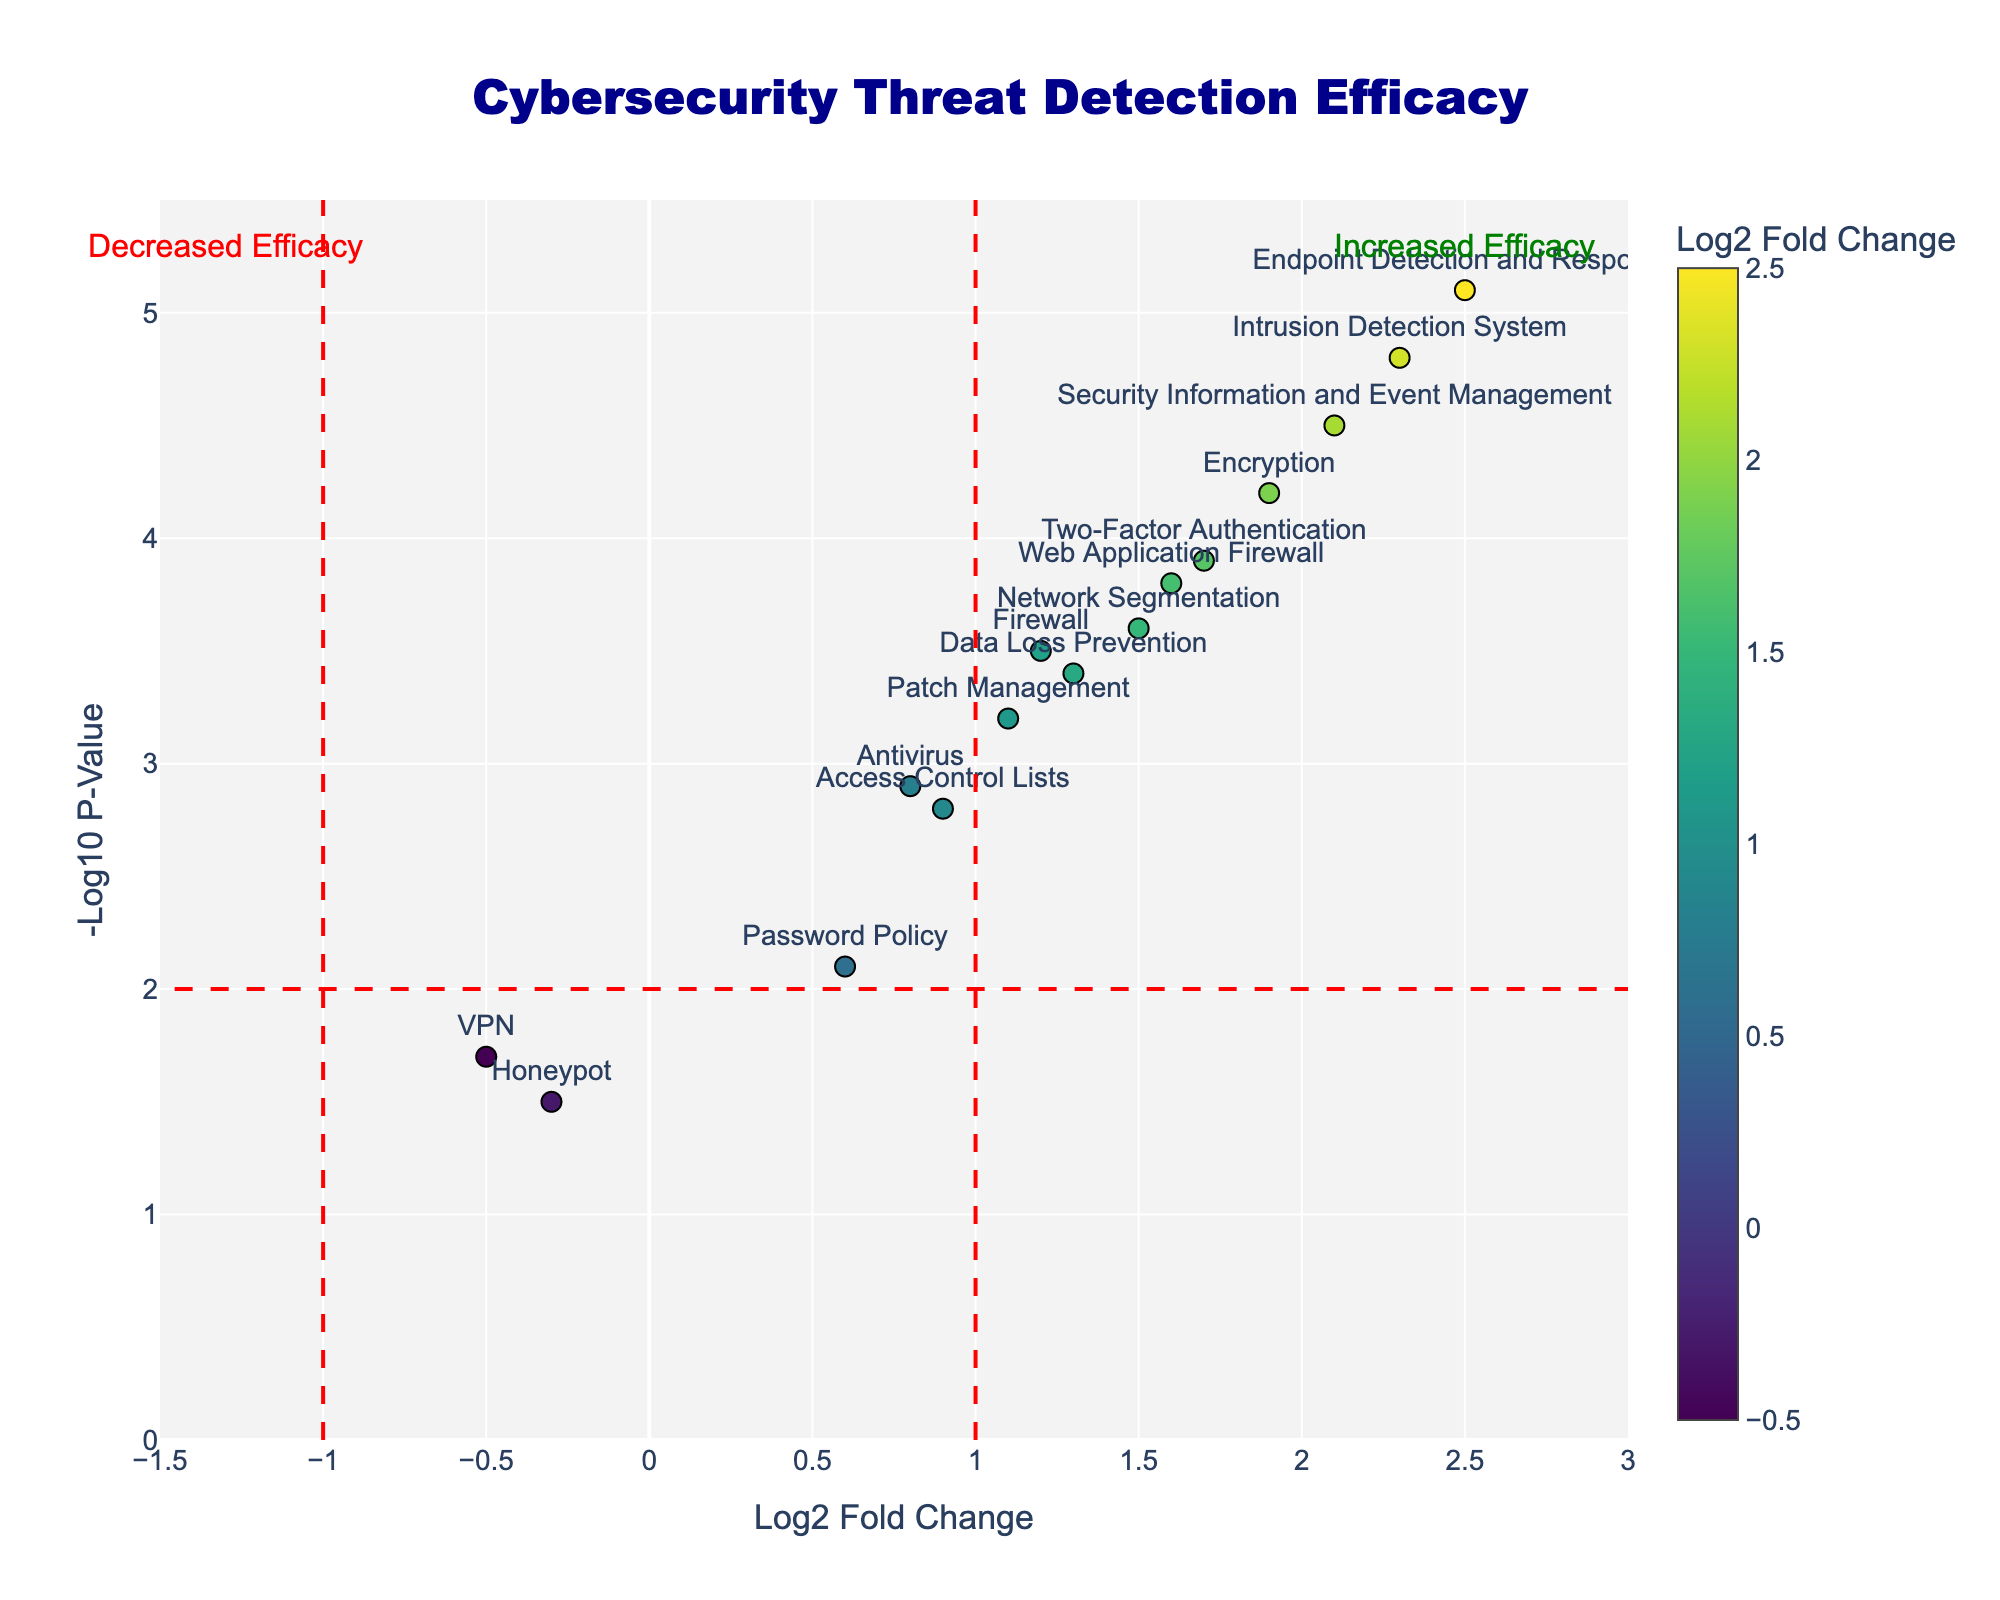What is the title of the figure? The title is usually displayed prominently at the top of the plot. Here, it is centered and reads "Cybersecurity Threat Detection Efficacy".
Answer: Cybersecurity Threat Detection Efficacy Which protocol has the highest efficacy according to the figure? To determine the protocol with the highest efficacy, look for the point highest on the y-axis. The highest point corresponds to the protocol "Endpoint Detection and Response" with Log2 Fold Change of 2.5 and a Negative Log10 P-Value of 5.1.
Answer: Endpoint Detection and Response What are the axes labels? The labels are typically found along each axis. Here, the x-axis is labeled "Log2 Fold Change" and the y-axis is labeled "-Log10 P-Value".
Answer: Log2 Fold Change and -Log10 P-Value Which security protocol shows a decrease in efficacy? A decrease in efficacy is indicated by a negative Log2 Fold Change. From the plot, the protocols with negative values on the x-axis are "VPN" and "Honeypot".
Answer: VPN and Honeypot How many protocols have a Negative Log10 P-Value higher than 4? To find this, count the points where the y-axis value is greater than 4. According to the plot, these protocols are "Intrusion Detection System", "Encryption", "Security Information and Event Management", and "Endpoint Detection and Response".
Answer: Four Which protocols fall within the increased efficacy region? The increased efficacy region is indicated by being to the right of the vertical line at x=1. The protocols in this region are "Intrusion Detection System", "Two-Factor Authentication", "Encryption", "Network Segmentation", "Security Information and Event Management", "Web Application Firewall", and "Endpoint Detection and Response".
Answer: IDS, 2FA, Encryption, Network Segmentation, SIEM, WAF, EDR Between "Firewall" and "Antivirus", which protocol has a higher efficacy and by how much? First, locate the points for "Firewall" and "Antivirus". "Firewall" has a Log2 Fold Change of 1.2, while "Antivirus" has 0.8. The difference in efficacy is 1.2 - 0.8 = 0.4.
Answer: Firewall by 0.4 What is the Log2 Fold Change of "Two-Factor Authentication"? Locate the point labeled "Two-Factor Authentication" and check its x-axis value. The Log2 Fold Change for this protocol is 1.7.
Answer: 1.7 Considering protocols with a Log2 Fold Change higher than 2, which has the lowest p-value? First, identify protocols with a Log2 Fold Change higher than 2: "Intrusion Detection System", "Security Information and Event Management", and "Endpoint Detection and Response". Among these, "Endpoint Detection and Response" has the highest point on the y-axis, corresponding to the lowest p-value.
Answer: Endpoint Detection and Response Which protocol with decreased efficacy has the highest p-value? Focus on protocols left of the zero mark (negative Log2 Fold Change): "VPN" and "Honeypot". Among these, "VPN" has a higher point on the y-axis, indicating a higher p-value.
Answer: VPN 